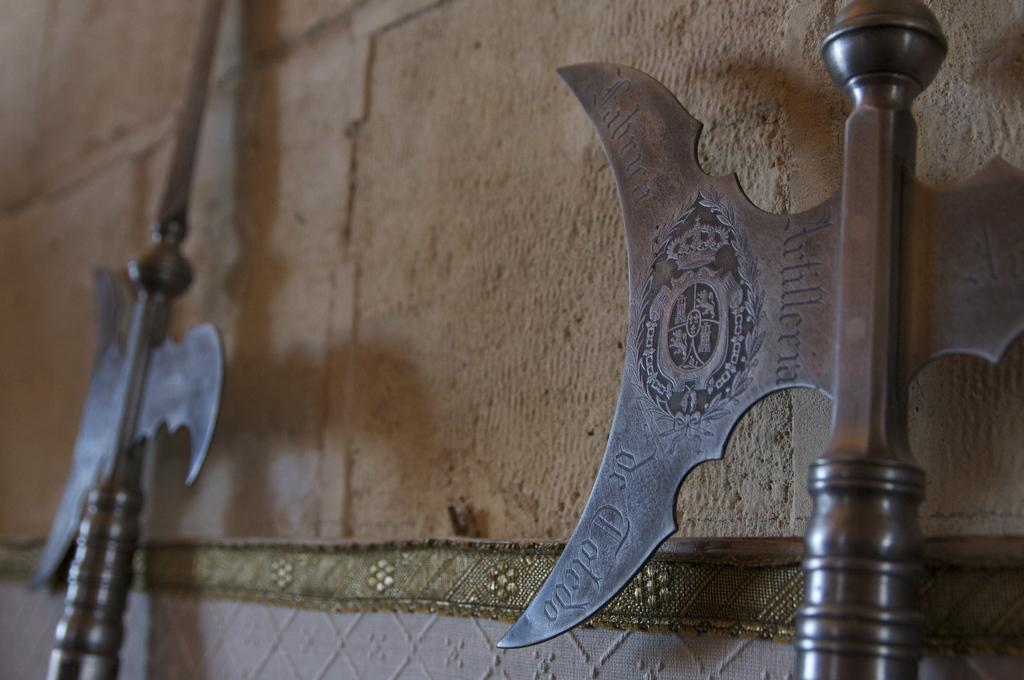What objects in the image are related to combat or defense? There are weapons in the image. What is the background or setting in the image? There is a wall in the image. How are the weapons decorated or designed? The weapons have designs on them. Are there any words or symbols on the weapons? Yes, there is writing on the weapons. Can you describe the mother sitting on the sofa in the image? There is no mother or sofa present in the image; it only features weapons and a wall. 